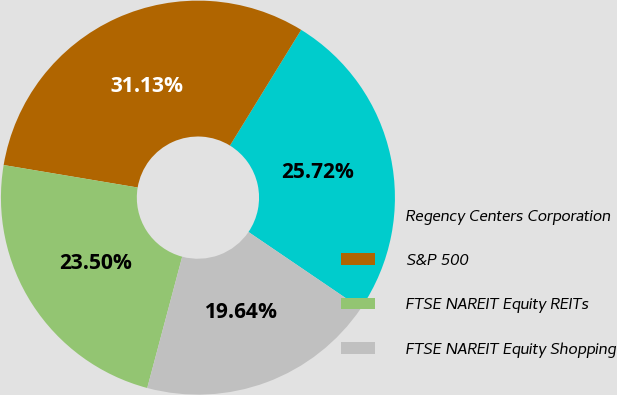<chart> <loc_0><loc_0><loc_500><loc_500><pie_chart><fcel>Regency Centers Corporation<fcel>S&P 500<fcel>FTSE NAREIT Equity REITs<fcel>FTSE NAREIT Equity Shopping<nl><fcel>25.72%<fcel>31.13%<fcel>23.5%<fcel>19.64%<nl></chart> 